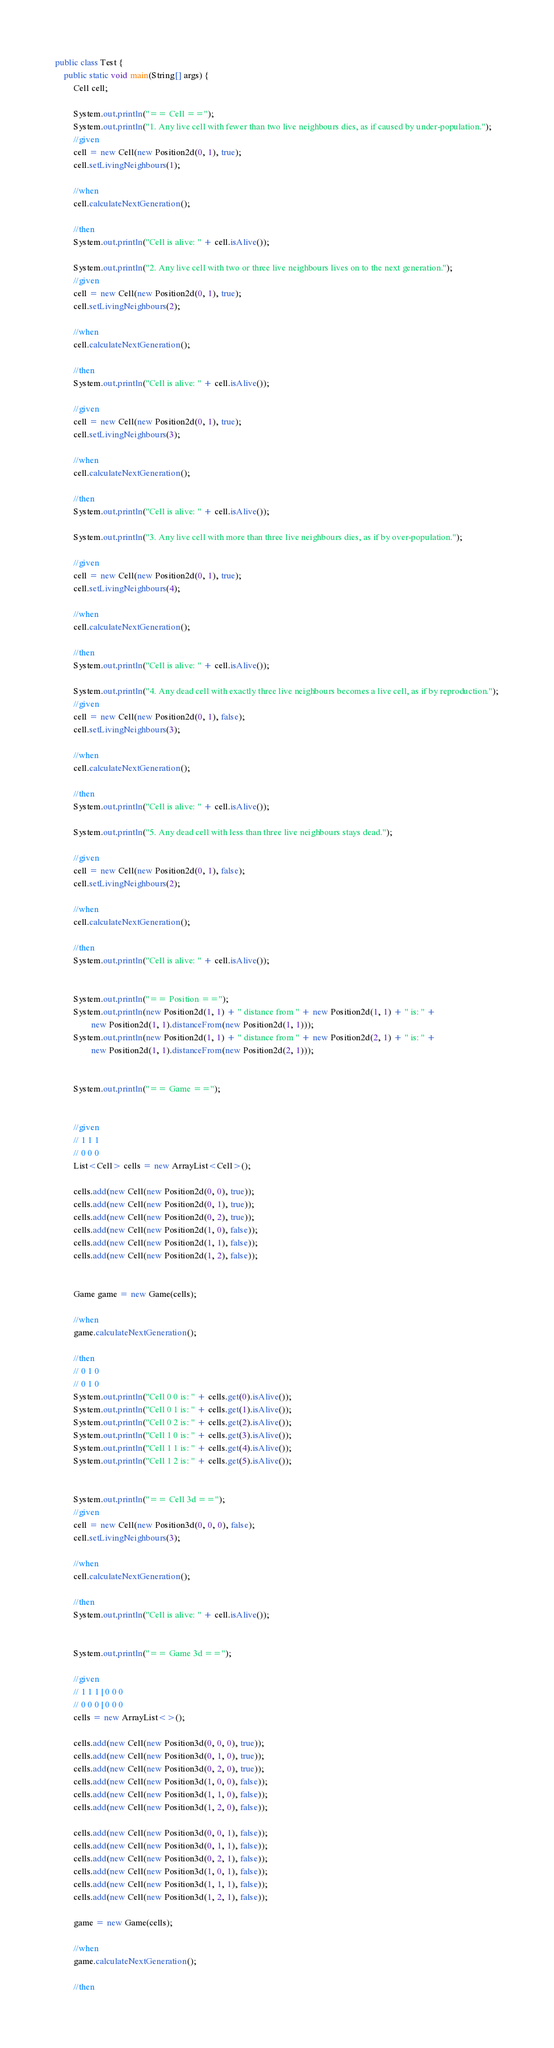<code> <loc_0><loc_0><loc_500><loc_500><_Java_>
public class Test {
    public static void main(String[] args) {
        Cell cell;

        System.out.println("== Cell ==");
        System.out.println("1. Any live cell with fewer than two live neighbours dies, as if caused by under-population.");
        //given
        cell = new Cell(new Position2d(0, 1), true);
        cell.setLivingNeighbours(1);

        //when
        cell.calculateNextGeneration();

        //then
        System.out.println("Cell is alive: " + cell.isAlive());

        System.out.println("2. Any live cell with two or three live neighbours lives on to the next generation.");
        //given
        cell = new Cell(new Position2d(0, 1), true);
        cell.setLivingNeighbours(2);

        //when
        cell.calculateNextGeneration();

        //then
        System.out.println("Cell is alive: " + cell.isAlive());

        //given
        cell = new Cell(new Position2d(0, 1), true);
        cell.setLivingNeighbours(3);

        //when
        cell.calculateNextGeneration();

        //then
        System.out.println("Cell is alive: " + cell.isAlive());

        System.out.println("3. Any live cell with more than three live neighbours dies, as if by over-population.");

        //given
        cell = new Cell(new Position2d(0, 1), true);
        cell.setLivingNeighbours(4);

        //when
        cell.calculateNextGeneration();

        //then
        System.out.println("Cell is alive: " + cell.isAlive());

        System.out.println("4. Any dead cell with exactly three live neighbours becomes a live cell, as if by reproduction.");
        //given
        cell = new Cell(new Position2d(0, 1), false);
        cell.setLivingNeighbours(3);

        //when
        cell.calculateNextGeneration();

        //then
        System.out.println("Cell is alive: " + cell.isAlive());

        System.out.println("5. Any dead cell with less than three live neighbours stays dead.");

        //given
        cell = new Cell(new Position2d(0, 1), false);
        cell.setLivingNeighbours(2);

        //when
        cell.calculateNextGeneration();

        //then
        System.out.println("Cell is alive: " + cell.isAlive());


        System.out.println("== Position ==");
        System.out.println(new Position2d(1, 1) + " distance from " + new Position2d(1, 1) + " is: " +
                new Position2d(1, 1).distanceFrom(new Position2d(1, 1)));
        System.out.println(new Position2d(1, 1) + " distance from " + new Position2d(2, 1) + " is: " +
                new Position2d(1, 1).distanceFrom(new Position2d(2, 1)));


        System.out.println("== Game ==");


        //given
        // 1 1 1
        // 0 0 0
        List<Cell> cells = new ArrayList<Cell>();

        cells.add(new Cell(new Position2d(0, 0), true));
        cells.add(new Cell(new Position2d(0, 1), true));
        cells.add(new Cell(new Position2d(0, 2), true));
        cells.add(new Cell(new Position2d(1, 0), false));
        cells.add(new Cell(new Position2d(1, 1), false));
        cells.add(new Cell(new Position2d(1, 2), false));


        Game game = new Game(cells);

        //when
        game.calculateNextGeneration();

        //then
        // 0 1 0
        // 0 1 0
        System.out.println("Cell 0 0 is: " + cells.get(0).isAlive());
        System.out.println("Cell 0 1 is: " + cells.get(1).isAlive());
        System.out.println("Cell 0 2 is: " + cells.get(2).isAlive());
        System.out.println("Cell 1 0 is: " + cells.get(3).isAlive());
        System.out.println("Cell 1 1 is: " + cells.get(4).isAlive());
        System.out.println("Cell 1 2 is: " + cells.get(5).isAlive());


        System.out.println("== Cell 3d ==");
        //given
        cell = new Cell(new Position3d(0, 0, 0), false);
        cell.setLivingNeighbours(3);

        //when
        cell.calculateNextGeneration();

        //then
        System.out.println("Cell is alive: " + cell.isAlive());


        System.out.println("== Game 3d ==");

        //given
        // 1 1 1 | 0 0 0
        // 0 0 0 | 0 0 0
        cells = new ArrayList<>();

        cells.add(new Cell(new Position3d(0, 0, 0), true));
        cells.add(new Cell(new Position3d(0, 1, 0), true));
        cells.add(new Cell(new Position3d(0, 2, 0), true));
        cells.add(new Cell(new Position3d(1, 0, 0), false));
        cells.add(new Cell(new Position3d(1, 1, 0), false));
        cells.add(new Cell(new Position3d(1, 2, 0), false));

        cells.add(new Cell(new Position3d(0, 0, 1), false));
        cells.add(new Cell(new Position3d(0, 1, 1), false));
        cells.add(new Cell(new Position3d(0, 2, 1), false));
        cells.add(new Cell(new Position3d(1, 0, 1), false));
        cells.add(new Cell(new Position3d(1, 1, 1), false));
        cells.add(new Cell(new Position3d(1, 2, 1), false));

        game = new Game(cells);

        //when
        game.calculateNextGeneration();

        //then</code> 